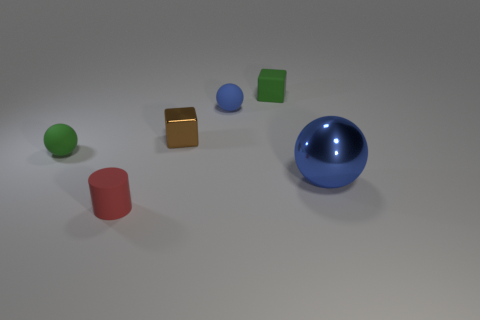There is a tiny green thing behind the tiny green thing that is to the left of the tiny shiny thing; what is its shape?
Provide a short and direct response. Cube. What color is the other tiny object that is the same shape as the brown shiny thing?
Make the answer very short. Green. Do the rubber ball behind the brown metal cube and the small green matte block have the same size?
Offer a terse response. Yes. What number of tiny red things are the same material as the small brown block?
Keep it short and to the point. 0. There is a blue sphere that is to the left of the ball that is in front of the green ball to the left of the big blue thing; what is it made of?
Your response must be concise. Rubber. What is the color of the small rubber sphere to the right of the ball that is left of the metallic block?
Keep it short and to the point. Blue. What color is the metal object that is the same size as the blue rubber thing?
Provide a short and direct response. Brown. What number of small objects are balls or yellow metallic cylinders?
Offer a terse response. 2. Is the number of large blue spheres to the left of the blue metallic thing greater than the number of small rubber balls behind the small blue sphere?
Provide a succinct answer. No. What is the size of the other object that is the same color as the big shiny object?
Ensure brevity in your answer.  Small. 